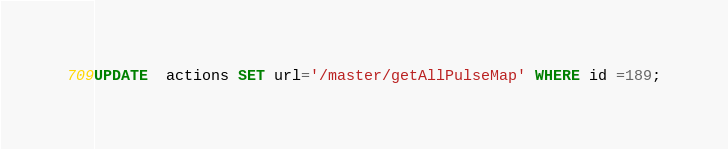Convert code to text. <code><loc_0><loc_0><loc_500><loc_500><_SQL_>UPDATE  actions SET url='/master/getAllPulseMap' WHERE id =189;</code> 